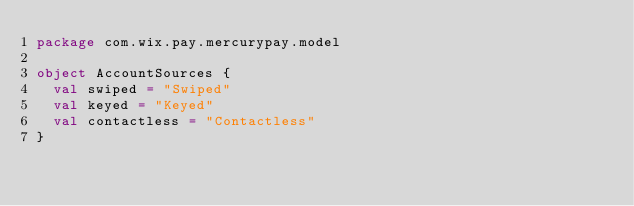Convert code to text. <code><loc_0><loc_0><loc_500><loc_500><_Scala_>package com.wix.pay.mercurypay.model

object AccountSources {
  val swiped = "Swiped"
  val keyed = "Keyed"
  val contactless = "Contactless"
}
</code> 